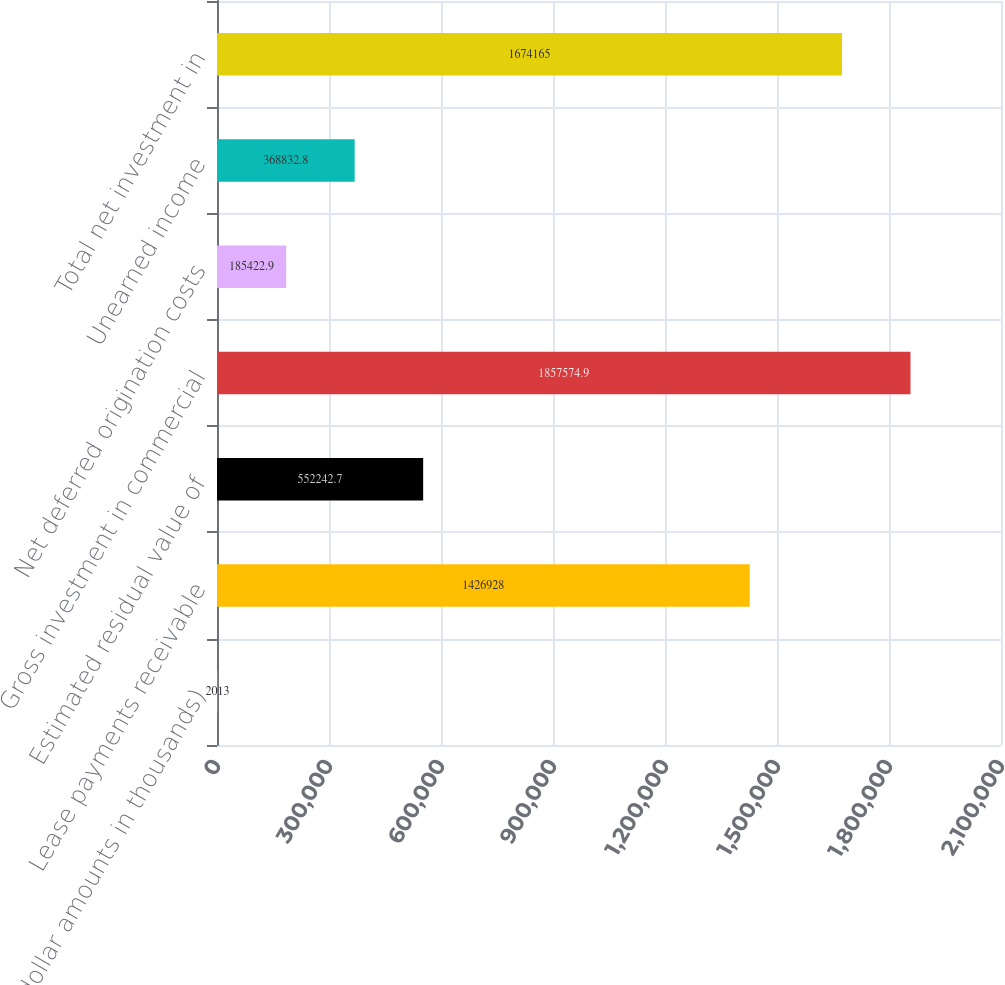Convert chart. <chart><loc_0><loc_0><loc_500><loc_500><bar_chart><fcel>(dollar amounts in thousands)<fcel>Lease payments receivable<fcel>Estimated residual value of<fcel>Gross investment in commercial<fcel>Net deferred origination costs<fcel>Unearned income<fcel>Total net investment in<nl><fcel>2013<fcel>1.42693e+06<fcel>552243<fcel>1.85757e+06<fcel>185423<fcel>368833<fcel>1.67416e+06<nl></chart> 